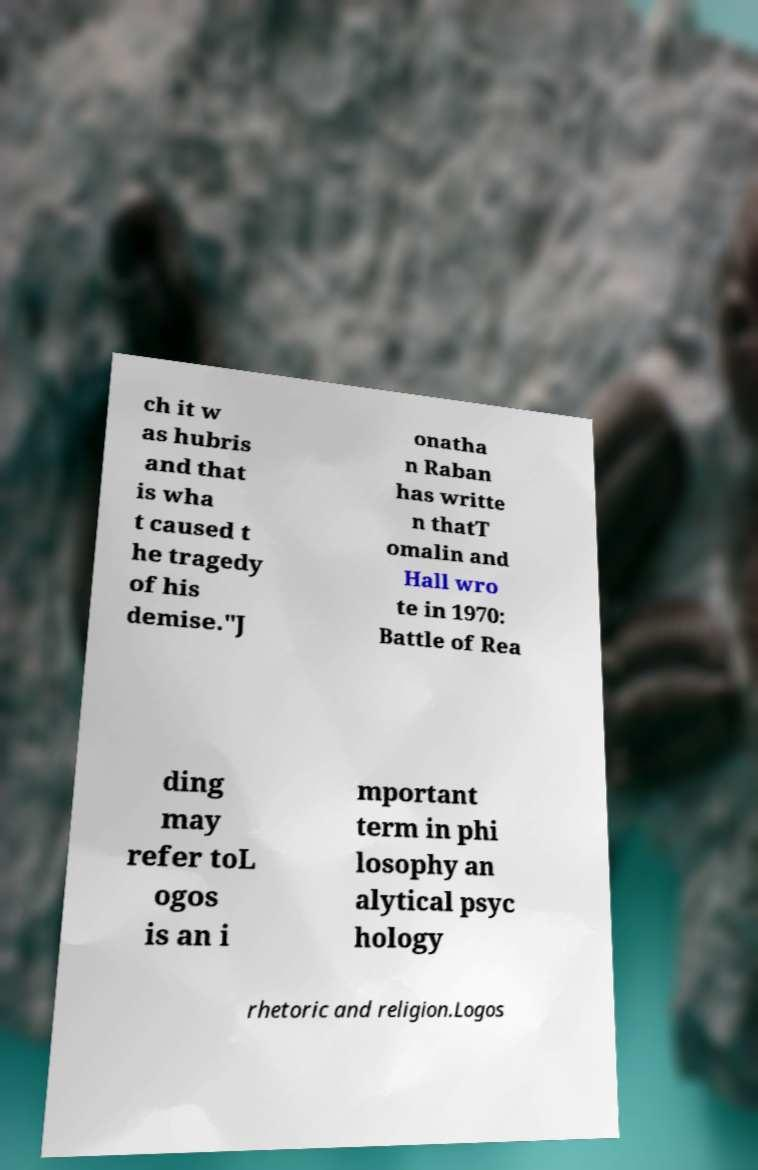Can you read and provide the text displayed in the image?This photo seems to have some interesting text. Can you extract and type it out for me? ch it w as hubris and that is wha t caused t he tragedy of his demise."J onatha n Raban has writte n thatT omalin and Hall wro te in 1970: Battle of Rea ding may refer toL ogos is an i mportant term in phi losophy an alytical psyc hology rhetoric and religion.Logos 